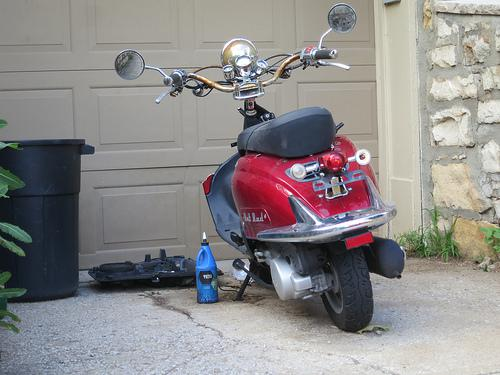Question: what type of vehicle is shown?
Choices:
A. A car.
B. A train.
C. Scooter.
D. A bicycle.
Answer with the letter. Answer: C Question: how many trashcans are there?
Choices:
A. One.
B. Two.
C. Three.
D. Four.
Answer with the letter. Answer: A Question: what is the wall to the right of the scooter made of?
Choices:
A. Stones.
B. Bricks.
C. Wood.
D. Tile.
Answer with the letter. Answer: A 